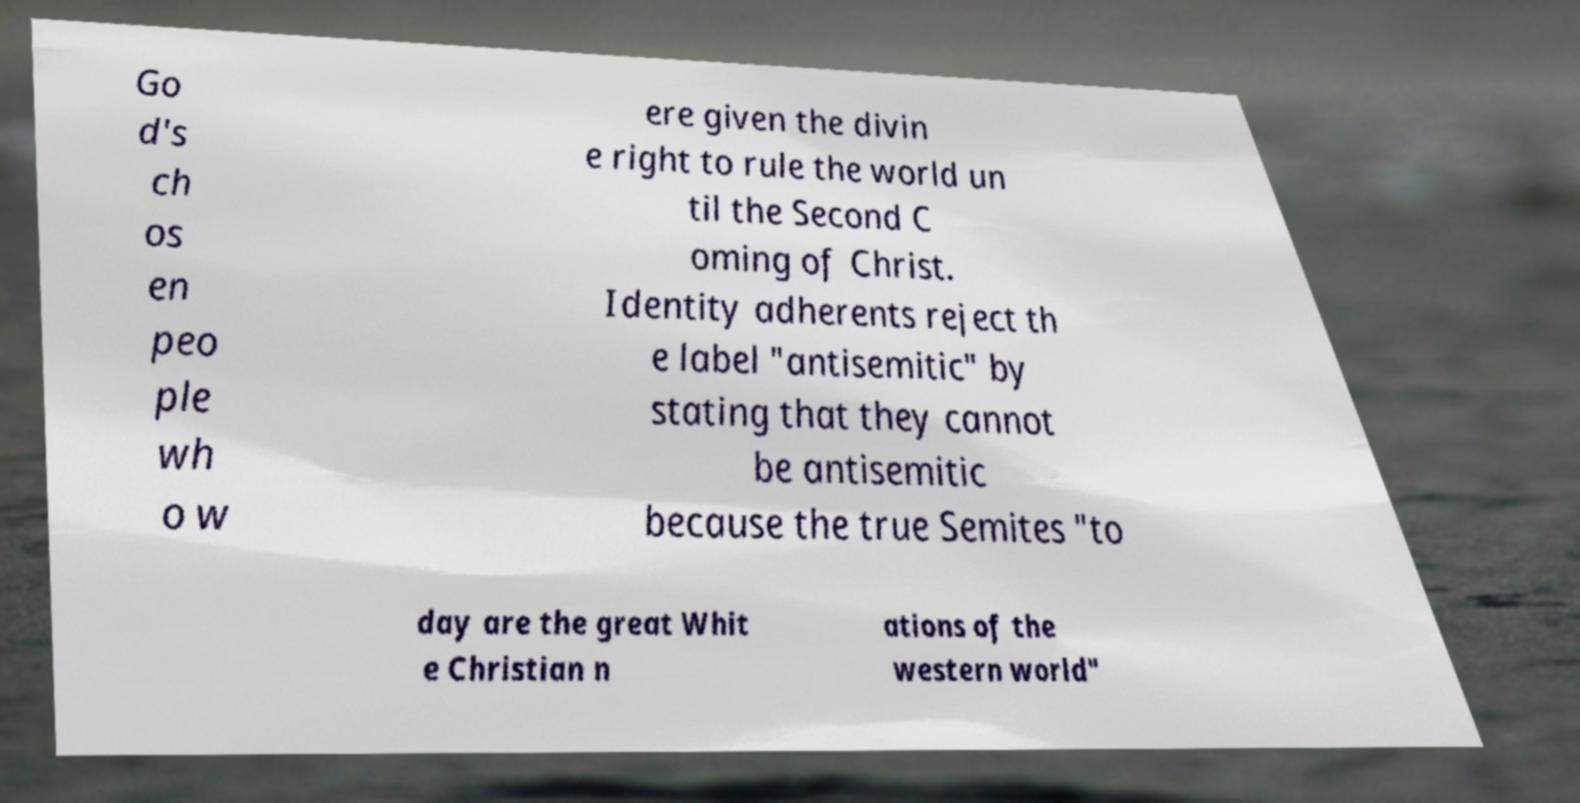Could you assist in decoding the text presented in this image and type it out clearly? Go d's ch os en peo ple wh o w ere given the divin e right to rule the world un til the Second C oming of Christ. Identity adherents reject th e label "antisemitic" by stating that they cannot be antisemitic because the true Semites "to day are the great Whit e Christian n ations of the western world" 